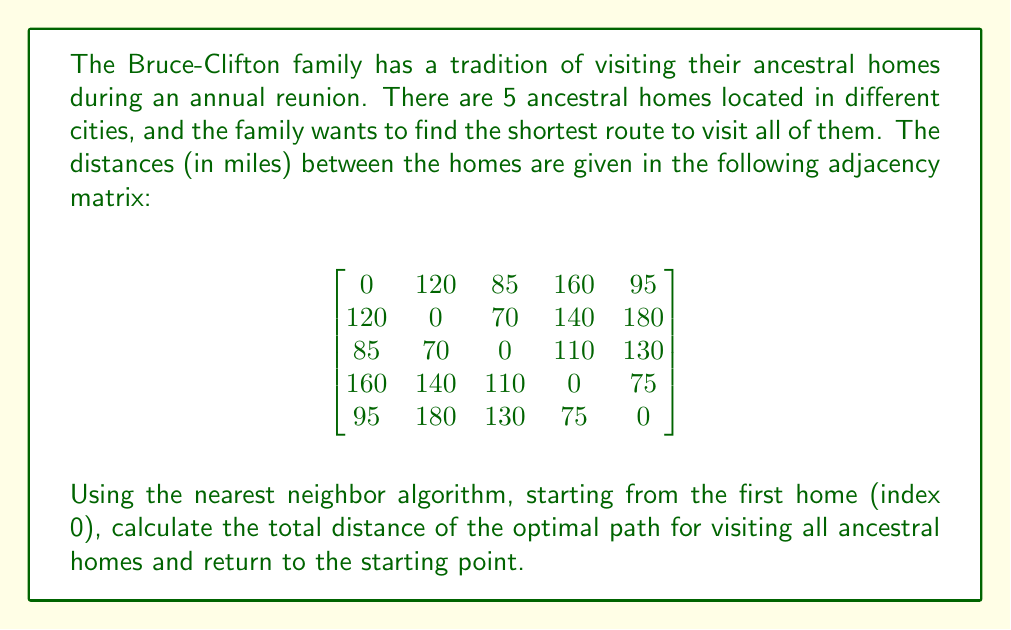Could you help me with this problem? To solve this problem using the nearest neighbor algorithm, we'll follow these steps:

1) Start at the first home (index 0).
2) Find the nearest unvisited home.
3) Move to that home and mark it as visited.
4) Repeat steps 2-3 until all homes are visited.
5) Return to the starting home.

Let's go through the process:

1) Start at home 0. Path: 0
   Unvisited homes: 1, 2, 3, 4

2) From 0, the nearest home is 2 (85 miles). 
   Path: 0 -> 2
   Distance so far: 85 miles
   Unvisited homes: 1, 3, 4

3) From 2, the nearest unvisited home is 3 (110 miles).
   Path: 0 -> 2 -> 3
   Distance so far: 85 + 110 = 195 miles
   Unvisited homes: 1, 4

4) From 3, the nearest unvisited home is 4 (75 miles).
   Path: 0 -> 2 -> 3 -> 4
   Distance so far: 195 + 75 = 270 miles
   Unvisited homes: 1

5) From 4, the only unvisited home is 1 (140 miles).
   Path: 0 -> 2 -> 3 -> 4 -> 1
   Distance so far: 270 + 140 = 410 miles
   All homes visited

6) Return to the starting point (home 0) from 1 (120 miles).
   Final path: 0 -> 2 -> 3 -> 4 -> 1 -> 0
   Total distance: 410 + 120 = 530 miles

Therefore, the optimal path using the nearest neighbor algorithm is 0 -> 2 -> 3 -> 4 -> 1 -> 0, with a total distance of 530 miles.
Answer: 530 miles 